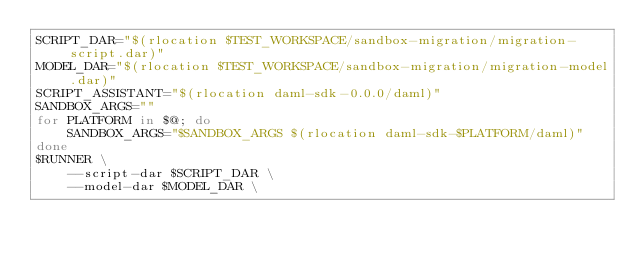<code> <loc_0><loc_0><loc_500><loc_500><_Bash_>SCRIPT_DAR="$(rlocation $TEST_WORKSPACE/sandbox-migration/migration-script.dar)"
MODEL_DAR="$(rlocation $TEST_WORKSPACE/sandbox-migration/migration-model.dar)"
SCRIPT_ASSISTANT="$(rlocation daml-sdk-0.0.0/daml)"
SANDBOX_ARGS=""
for PLATFORM in $@; do
    SANDBOX_ARGS="$SANDBOX_ARGS $(rlocation daml-sdk-$PLATFORM/daml)"
done
$RUNNER \
    --script-dar $SCRIPT_DAR \
    --model-dar $MODEL_DAR \</code> 